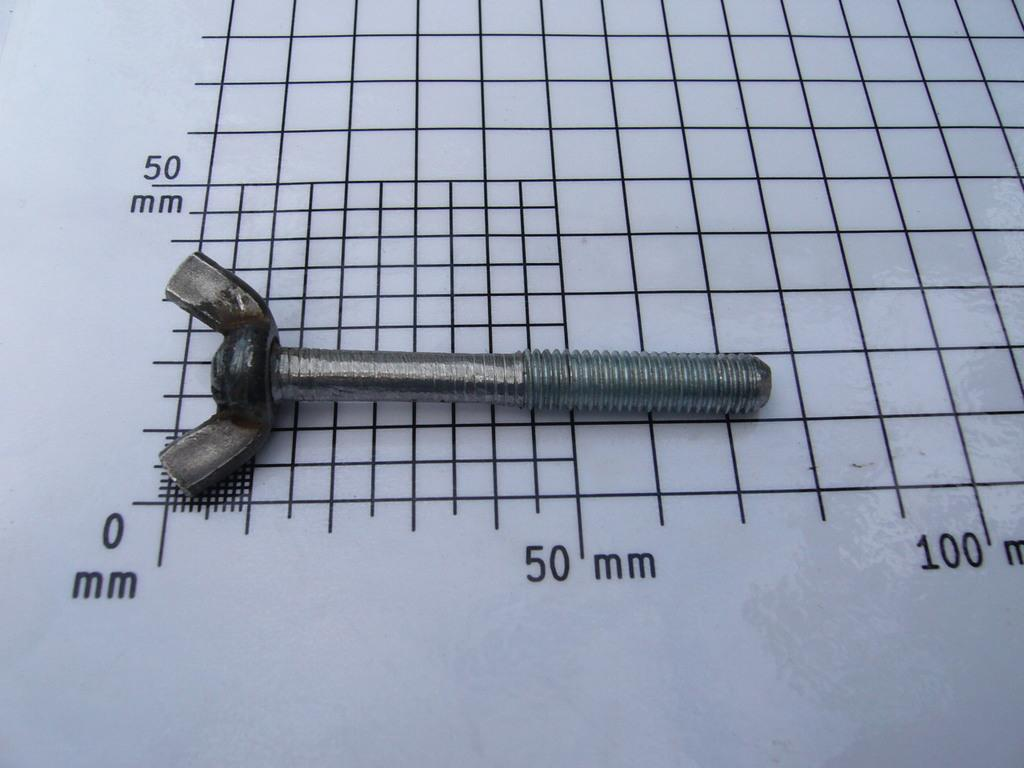What type of tool is in the image? There is a diagonal pliers in the image. What is the diagonal pliers placed on? The diagonal pliers are on a paper. What type of dinosaur can be seen reading a book in the image? There are no dinosaurs or books present in the image; it features a diagonal pliers on a paper. 